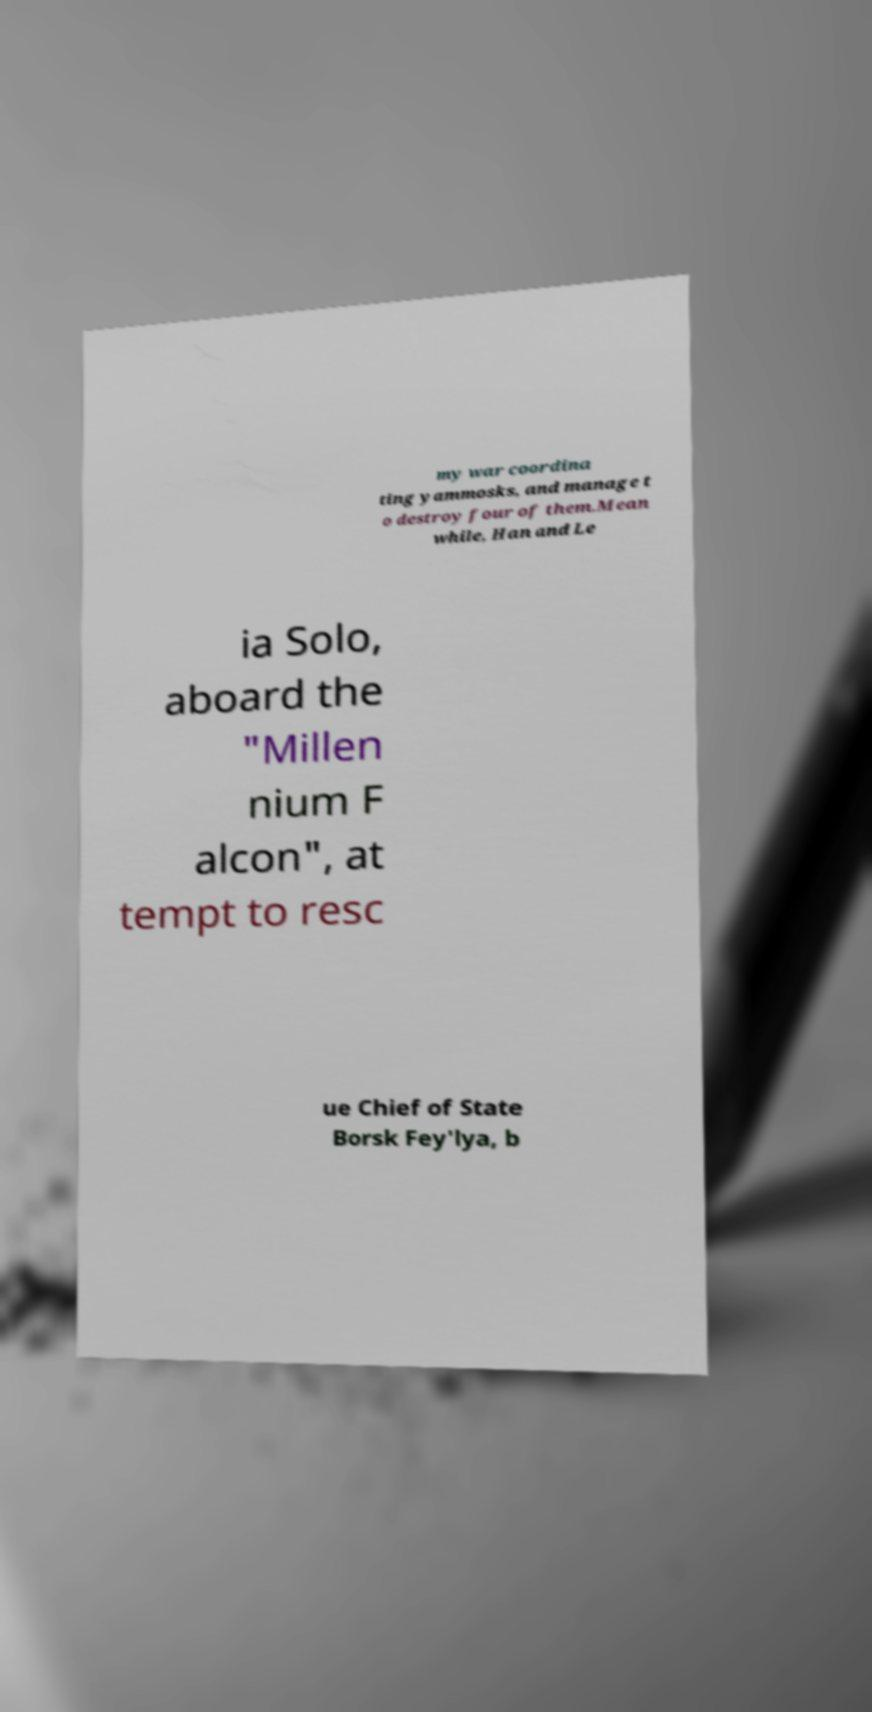Please identify and transcribe the text found in this image. my war coordina ting yammosks, and manage t o destroy four of them.Mean while, Han and Le ia Solo, aboard the "Millen nium F alcon", at tempt to resc ue Chief of State Borsk Fey'lya, b 